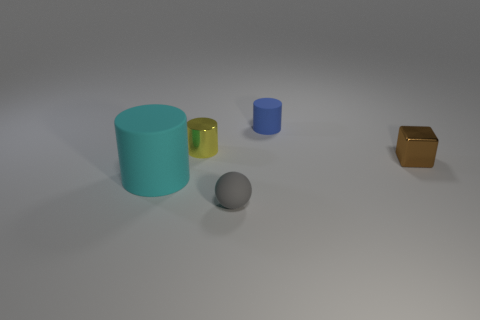Add 1 large purple matte blocks. How many objects exist? 6 Subtract all blocks. How many objects are left? 4 Subtract all balls. Subtract all cubes. How many objects are left? 3 Add 4 yellow metallic cylinders. How many yellow metallic cylinders are left? 5 Add 1 cubes. How many cubes exist? 2 Subtract 1 brown blocks. How many objects are left? 4 